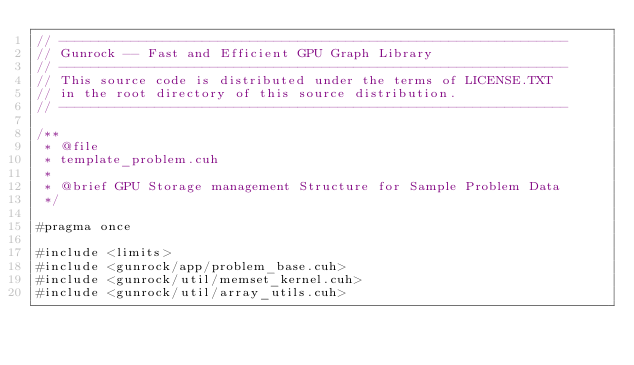<code> <loc_0><loc_0><loc_500><loc_500><_Cuda_>// ----------------------------------------------------------------
// Gunrock -- Fast and Efficient GPU Graph Library
// ----------------------------------------------------------------
// This source code is distributed under the terms of LICENSE.TXT
// in the root directory of this source distribution.
// ----------------------------------------------------------------

/**
 * @file
 * template_problem.cuh
 *
 * @brief GPU Storage management Structure for Sample Problem Data
 */

#pragma once

#include <limits>
#include <gunrock/app/problem_base.cuh>
#include <gunrock/util/memset_kernel.cuh>
#include <gunrock/util/array_utils.cuh>
</code> 